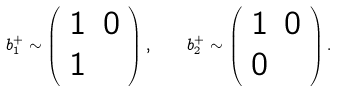<formula> <loc_0><loc_0><loc_500><loc_500>b _ { 1 } ^ { + } \sim \left ( \begin{array} { c c } 1 & 0 \\ 1 & \end{array} \right ) , \quad b _ { 2 } ^ { + } \sim \left ( \begin{array} { c c } 1 & 0 \\ 0 & \end{array} \right ) .</formula> 